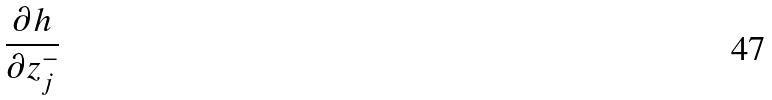Convert formula to latex. <formula><loc_0><loc_0><loc_500><loc_500>\frac { \partial h } { \partial z _ { j } ^ { - } }</formula> 